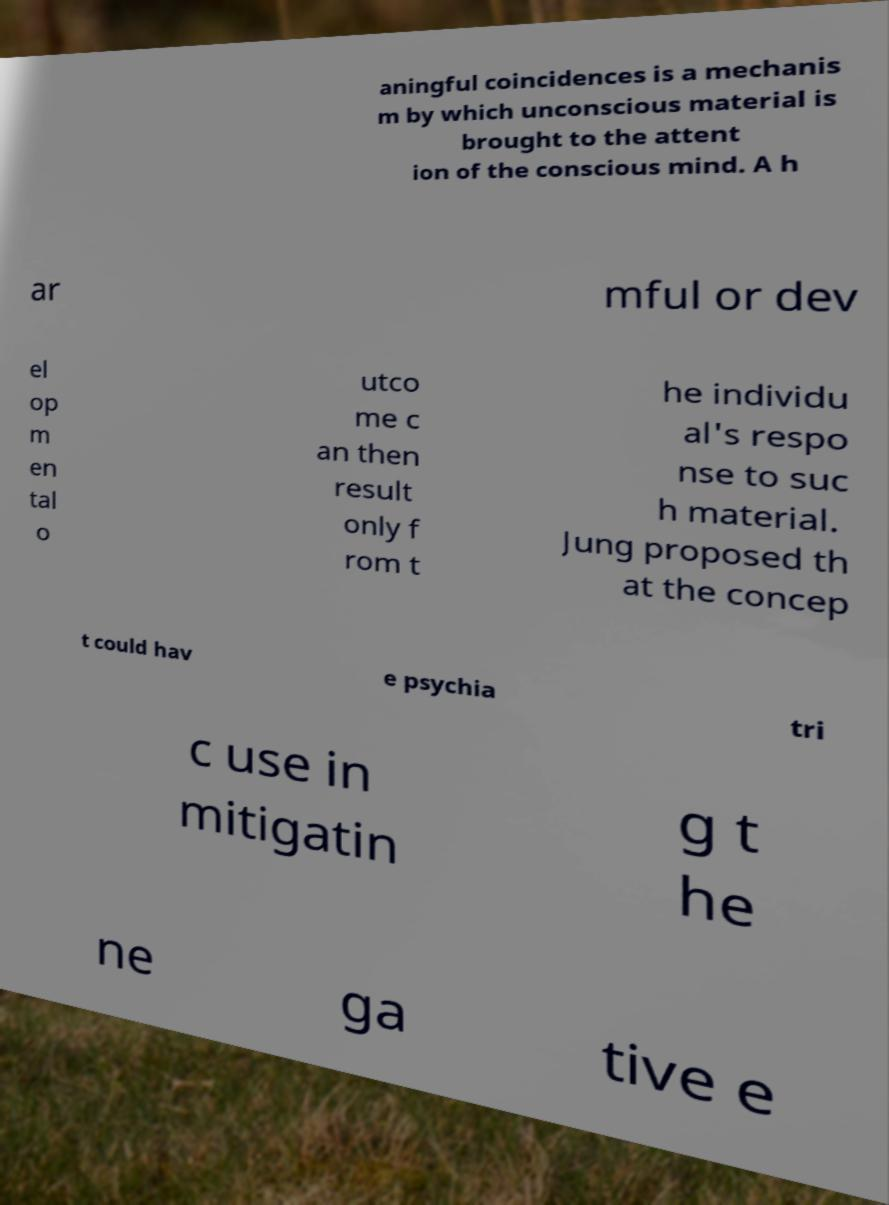What messages or text are displayed in this image? I need them in a readable, typed format. aningful coincidences is a mechanis m by which unconscious material is brought to the attent ion of the conscious mind. A h ar mful or dev el op m en tal o utco me c an then result only f rom t he individu al's respo nse to suc h material. Jung proposed th at the concep t could hav e psychia tri c use in mitigatin g t he ne ga tive e 